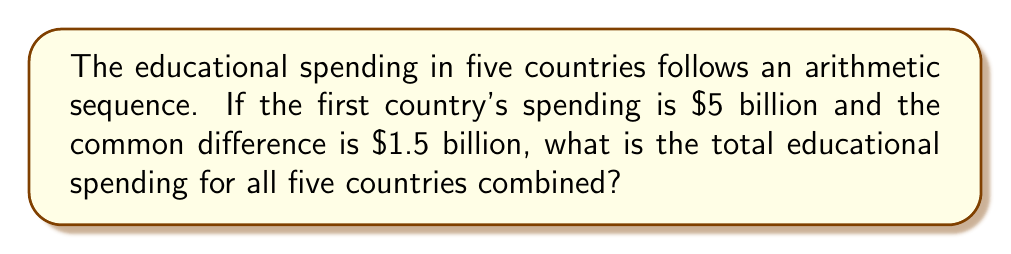Give your solution to this math problem. To solve this problem, we need to follow these steps:

1. Identify the arithmetic sequence:
   - First term (a₁) = $5 billion
   - Common difference (d) = $1.5 billion
   - Number of terms (n) = 5 countries

2. Calculate the spending for each country:
   - Country 1: $a_1 = 5$ billion
   - Country 2: $a_2 = a_1 + d = 5 + 1.5 = 6.5$ billion
   - Country 3: $a_3 = a_2 + d = 6.5 + 1.5 = 8$ billion
   - Country 4: $a_4 = a_3 + d = 8 + 1.5 = 9.5$ billion
   - Country 5: $a_5 = a_4 + d = 9.5 + 1.5 = 11$ billion

3. Use the arithmetic sequence sum formula:
   $$S_n = \frac{n}{2}(a_1 + a_n)$$
   Where:
   $S_n$ is the sum of the sequence
   $n$ is the number of terms
   $a_1$ is the first term
   $a_n$ is the last term

4. Plug in the values:
   $$S_5 = \frac{5}{2}(5 + 11)$$

5. Calculate the result:
   $$S_5 = \frac{5}{2}(16) = 5(8) = 40$$

Therefore, the total educational spending for all five countries combined is $40 billion.
Answer: $40 billion 